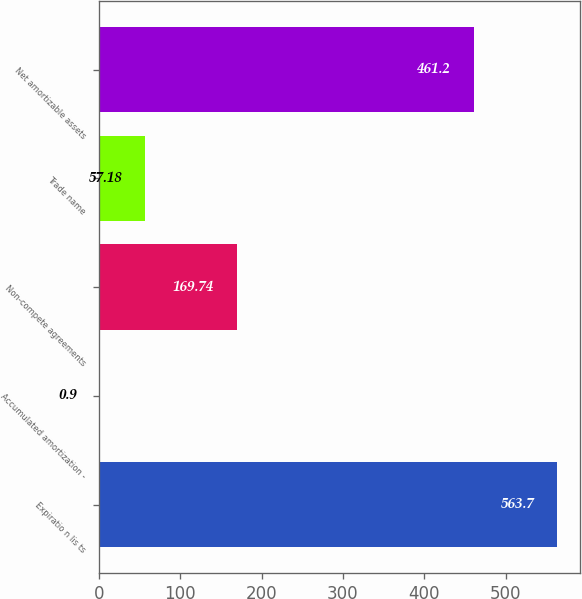<chart> <loc_0><loc_0><loc_500><loc_500><bar_chart><fcel>Expiratio n lis ts<fcel>Accumulated amortization -<fcel>Non-compete agreements<fcel>Trade name<fcel>Net amortizable assets<nl><fcel>563.7<fcel>0.9<fcel>169.74<fcel>57.18<fcel>461.2<nl></chart> 